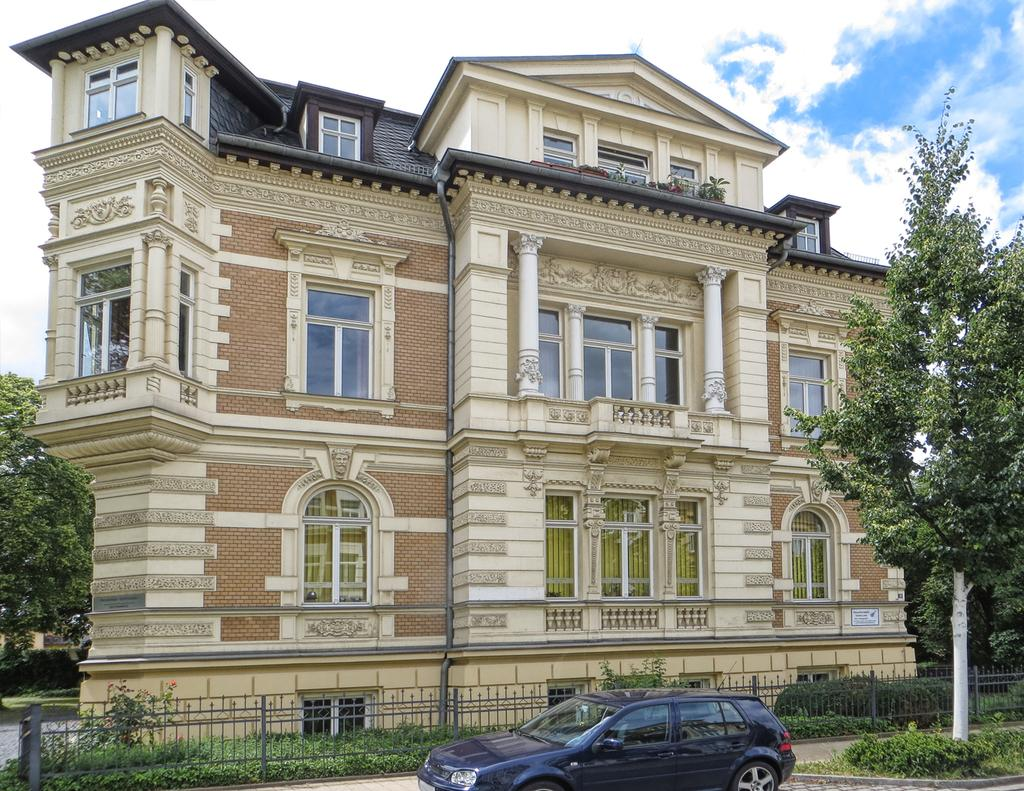What type of structure is visible in the image? There is a building in the image. What natural elements can be seen in the image? There are trees and plants in the image. What type of barrier is present in the image? There is a metal fence in the image. What mode of transportation is visible in the image? There is a car in the image. What is the condition of the sky in the image? The sky is blue and cloudy in the image. Can you tell me how many police officers are present in the image? There is no mention of police officers in the image; it features a building, trees, a metal fence, a car, plants, and a blue and cloudy sky. What type of country is depicted in the image? The image does not depict a country; it shows a building, trees, a metal fence, a car, plants, and a blue and cloudy sky. 